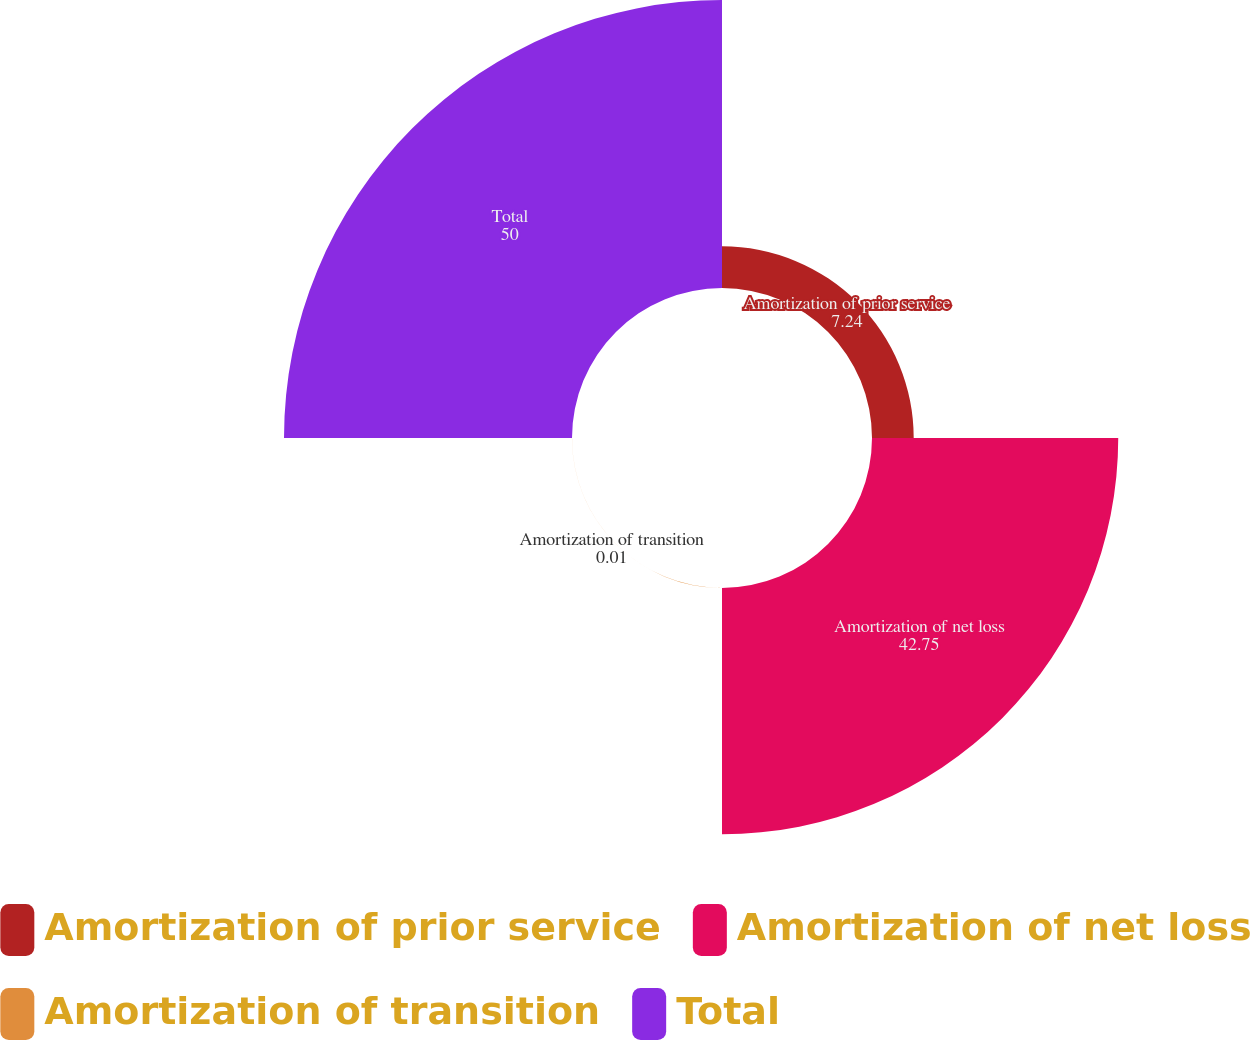Convert chart. <chart><loc_0><loc_0><loc_500><loc_500><pie_chart><fcel>Amortization of prior service<fcel>Amortization of net loss<fcel>Amortization of transition<fcel>Total<nl><fcel>7.24%<fcel>42.75%<fcel>0.01%<fcel>50.0%<nl></chart> 